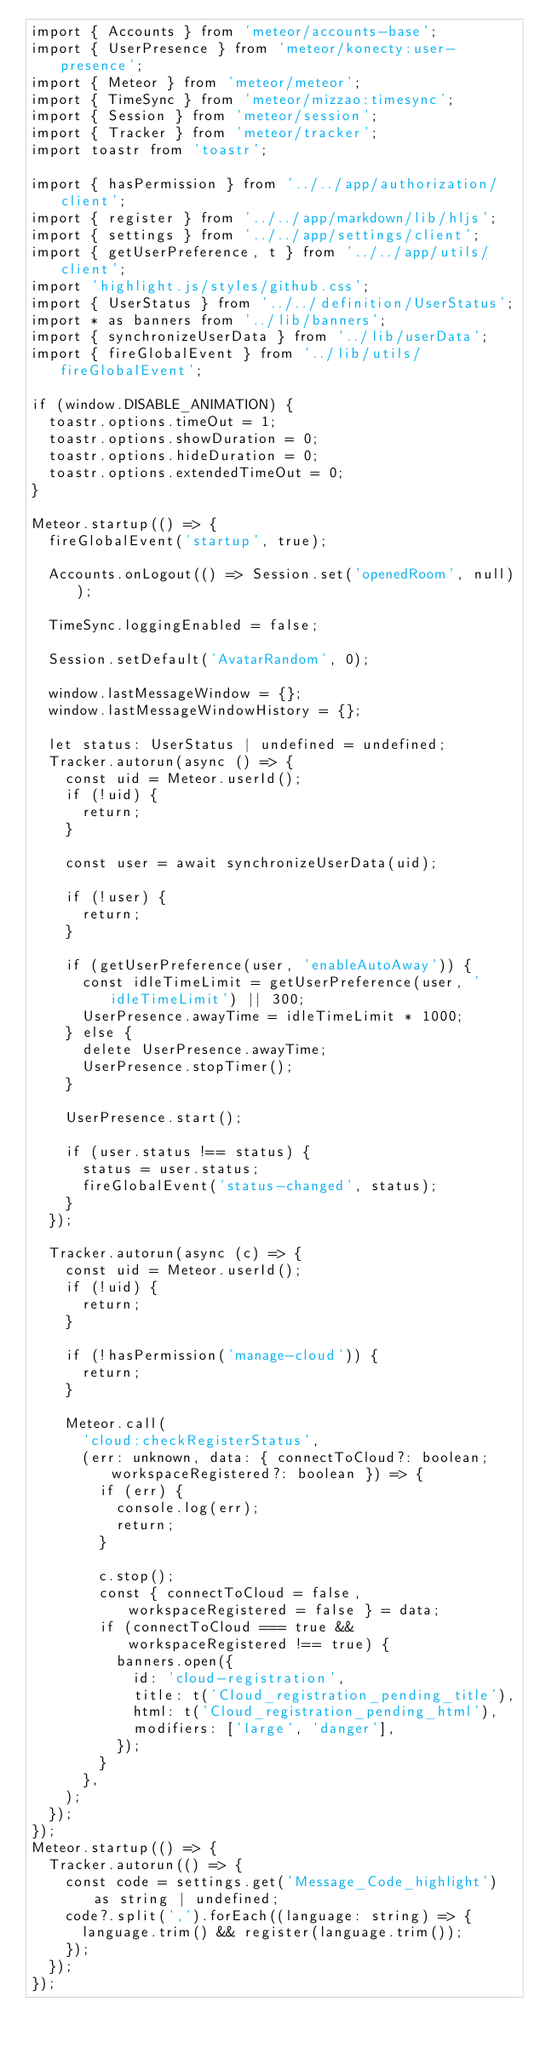Convert code to text. <code><loc_0><loc_0><loc_500><loc_500><_TypeScript_>import { Accounts } from 'meteor/accounts-base';
import { UserPresence } from 'meteor/konecty:user-presence';
import { Meteor } from 'meteor/meteor';
import { TimeSync } from 'meteor/mizzao:timesync';
import { Session } from 'meteor/session';
import { Tracker } from 'meteor/tracker';
import toastr from 'toastr';

import { hasPermission } from '../../app/authorization/client';
import { register } from '../../app/markdown/lib/hljs';
import { settings } from '../../app/settings/client';
import { getUserPreference, t } from '../../app/utils/client';
import 'highlight.js/styles/github.css';
import { UserStatus } from '../../definition/UserStatus';
import * as banners from '../lib/banners';
import { synchronizeUserData } from '../lib/userData';
import { fireGlobalEvent } from '../lib/utils/fireGlobalEvent';

if (window.DISABLE_ANIMATION) {
	toastr.options.timeOut = 1;
	toastr.options.showDuration = 0;
	toastr.options.hideDuration = 0;
	toastr.options.extendedTimeOut = 0;
}

Meteor.startup(() => {
	fireGlobalEvent('startup', true);

	Accounts.onLogout(() => Session.set('openedRoom', null));

	TimeSync.loggingEnabled = false;

	Session.setDefault('AvatarRandom', 0);

	window.lastMessageWindow = {};
	window.lastMessageWindowHistory = {};

	let status: UserStatus | undefined = undefined;
	Tracker.autorun(async () => {
		const uid = Meteor.userId();
		if (!uid) {
			return;
		}

		const user = await synchronizeUserData(uid);

		if (!user) {
			return;
		}

		if (getUserPreference(user, 'enableAutoAway')) {
			const idleTimeLimit = getUserPreference(user, 'idleTimeLimit') || 300;
			UserPresence.awayTime = idleTimeLimit * 1000;
		} else {
			delete UserPresence.awayTime;
			UserPresence.stopTimer();
		}

		UserPresence.start();

		if (user.status !== status) {
			status = user.status;
			fireGlobalEvent('status-changed', status);
		}
	});

	Tracker.autorun(async (c) => {
		const uid = Meteor.userId();
		if (!uid) {
			return;
		}

		if (!hasPermission('manage-cloud')) {
			return;
		}

		Meteor.call(
			'cloud:checkRegisterStatus',
			(err: unknown, data: { connectToCloud?: boolean; workspaceRegistered?: boolean }) => {
				if (err) {
					console.log(err);
					return;
				}

				c.stop();
				const { connectToCloud = false, workspaceRegistered = false } = data;
				if (connectToCloud === true && workspaceRegistered !== true) {
					banners.open({
						id: 'cloud-registration',
						title: t('Cloud_registration_pending_title'),
						html: t('Cloud_registration_pending_html'),
						modifiers: ['large', 'danger'],
					});
				}
			},
		);
	});
});
Meteor.startup(() => {
	Tracker.autorun(() => {
		const code = settings.get('Message_Code_highlight') as string | undefined;
		code?.split(',').forEach((language: string) => {
			language.trim() && register(language.trim());
		});
	});
});
</code> 